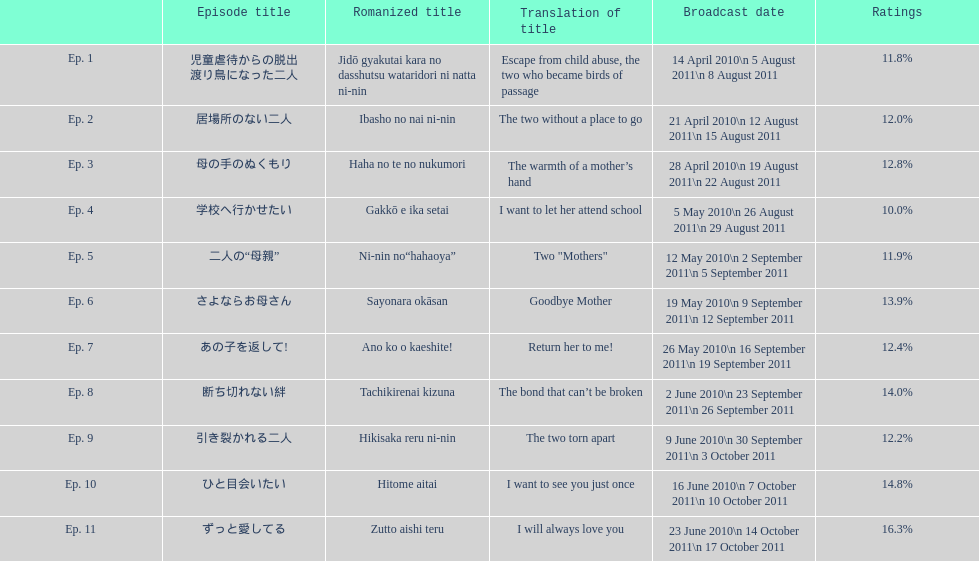What is the name of this series' premiere episode? 児童虐待からの脱出 渡り鳥になった二人. 